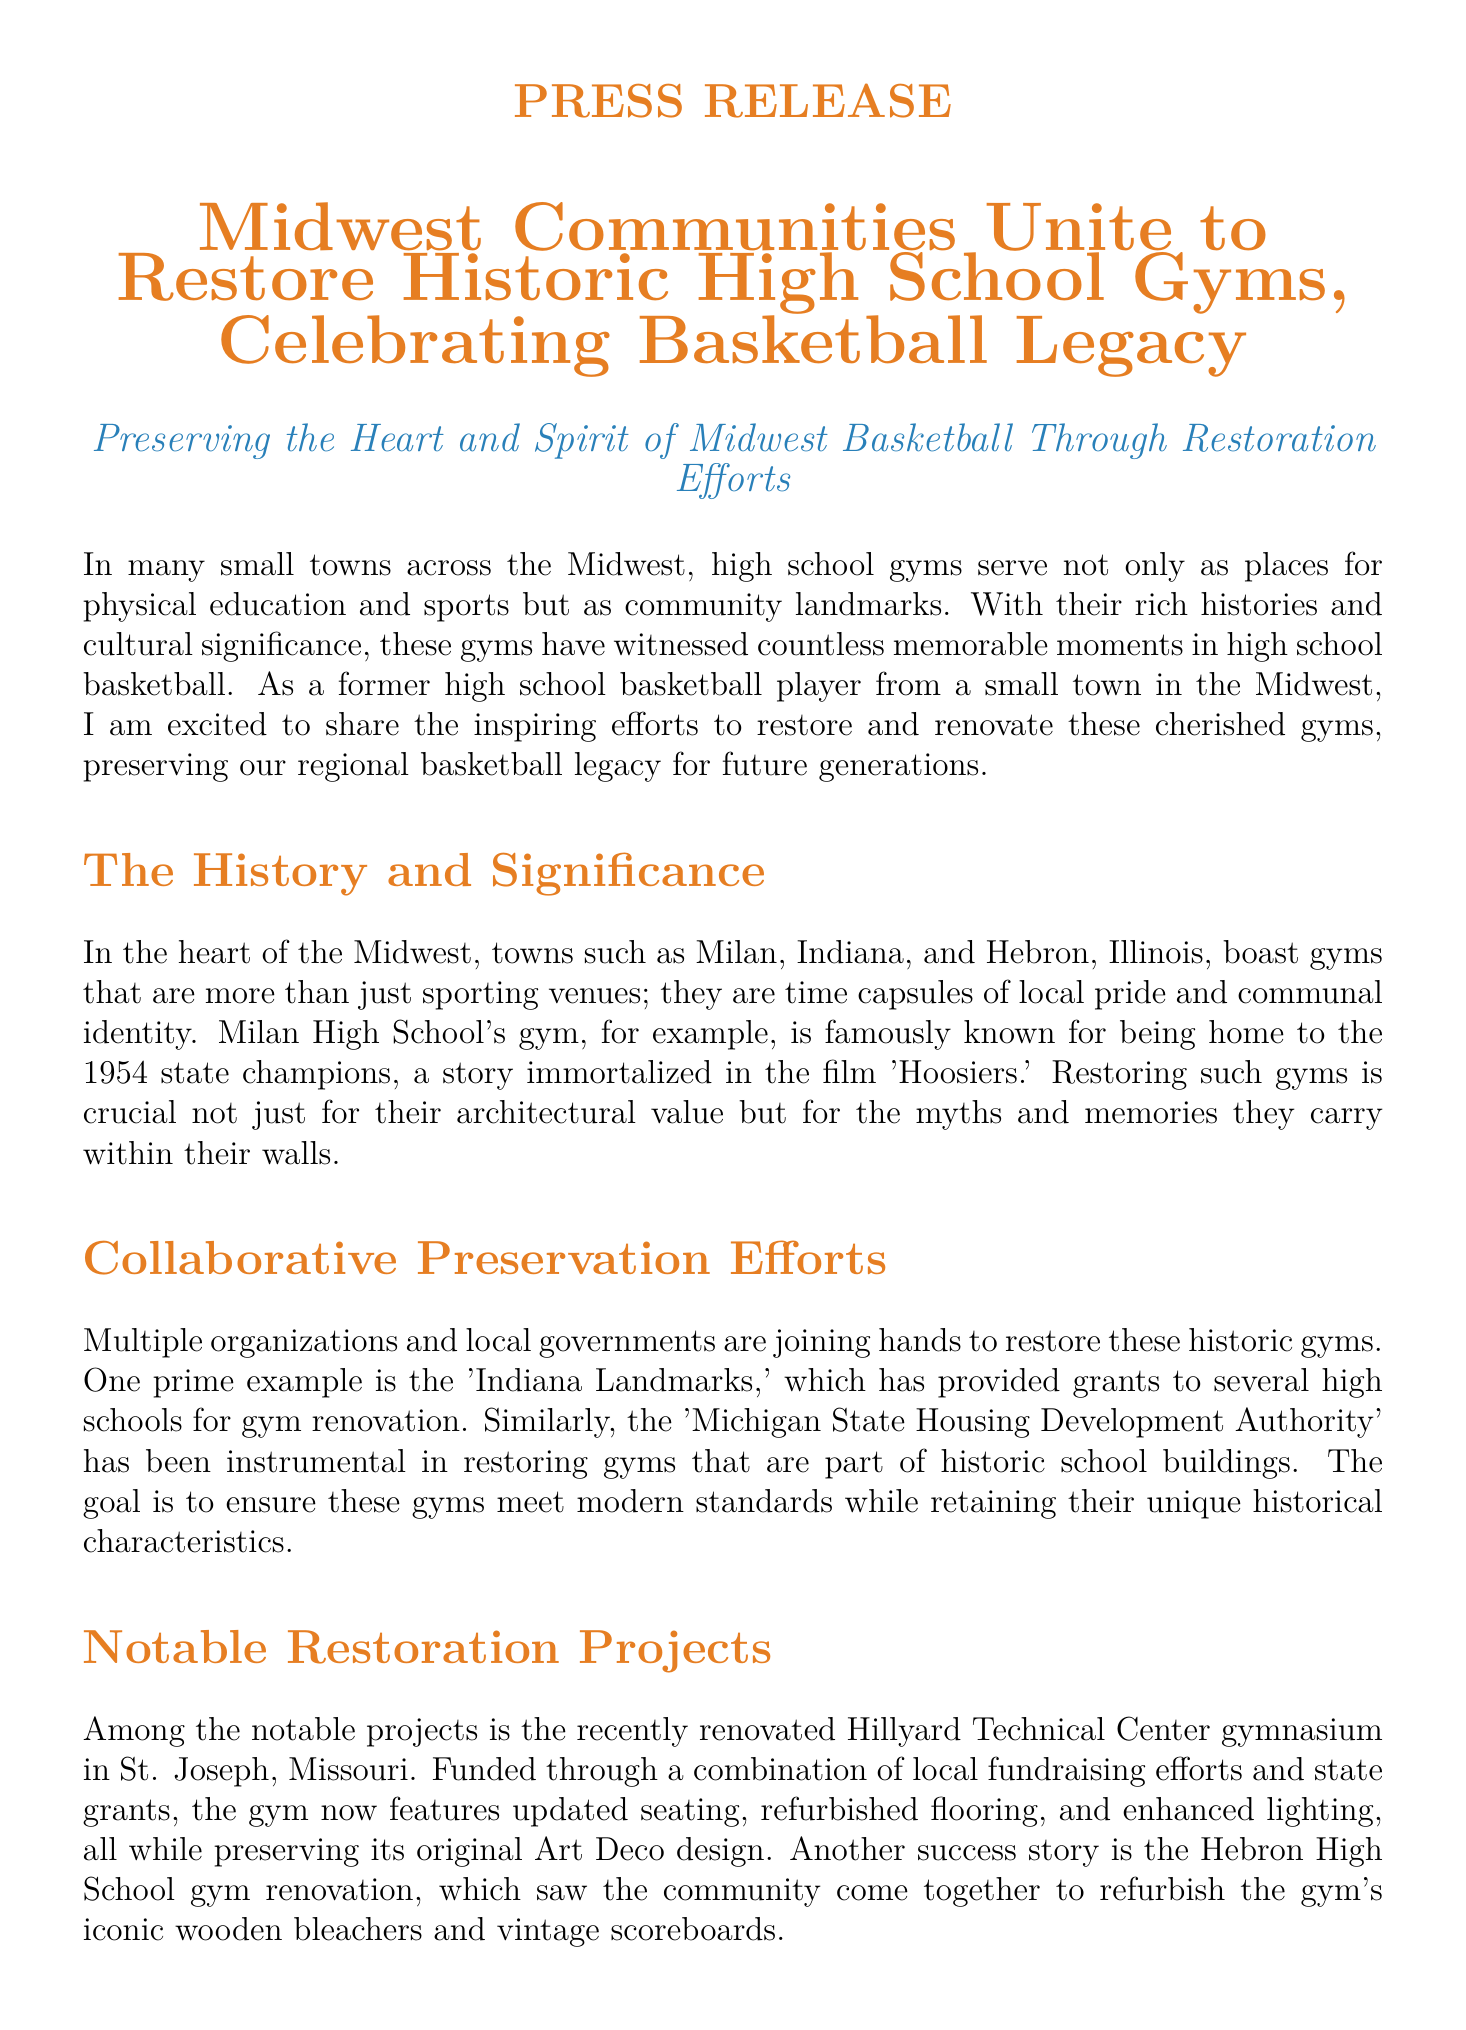What towns are mentioned as having historic gyms? The document mentions Milan, Indiana, and Hebron, Illinois as towns with historic gyms.
Answer: Milan, Indiana and Hebron, Illinois What organization provided grants for gym renovation? The organization mentioned in the document that provided grants for renovations is 'Indiana Landmarks.'
Answer: Indiana Landmarks What is the notable feature of the Hillyard Technical Center gym? The Hillyard Technical Center gym is distinguished by its original Art Deco design which was preserved during renovation.
Answer: Art Deco design How many notable restoration projects are mentioned? The document outlines two notable restoration projects: Hillyard Technical Center gym and Hebron High School gym.
Answer: Two What impact has the restoration led to within communities? The restoration projects have led to increased community engagement among residents, alumni, and students.
Answer: Increased community engagement What is the call to action mentioned in the document? The document encourages participation in the ongoing efforts through donations, volunteer work, or sharing stories.
Answer: Donations, volunteer work, sharing stories What year’s state championships is associated with Milan High School's gym? The Milan High School gym is associated with the 1954 state championships.
Answer: 1954 Which authority has been involved in restoring gyms in historic school buildings? The Michigan State Housing Development Authority is mentioned as being involved in these restoration efforts.
Answer: Michigan State Housing Development Authority 